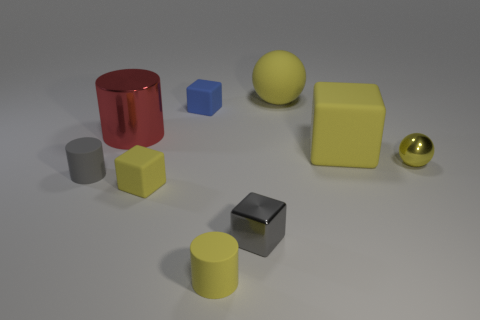Is there a small yellow rubber cube that is right of the yellow sphere that is in front of the small thing behind the tiny yellow ball?
Your response must be concise. No. What is the size of the rubber cylinder that is the same color as the metallic block?
Keep it short and to the point. Small. Are there any big matte things on the left side of the tiny yellow matte block?
Make the answer very short. No. How many other things are there of the same shape as the tiny gray rubber object?
Ensure brevity in your answer.  2. The shiny sphere that is the same size as the gray metallic thing is what color?
Make the answer very short. Yellow. Are there fewer things that are behind the gray cylinder than big red objects on the right side of the blue matte cube?
Offer a very short reply. No. How many large objects are in front of the yellow sphere left of the yellow ball that is in front of the big ball?
Your answer should be very brief. 2. The yellow object that is the same shape as the tiny gray matte object is what size?
Your answer should be very brief. Small. Are there any other things that are the same size as the yellow rubber ball?
Give a very brief answer. Yes. Are there fewer small gray shiny blocks that are behind the small shiny sphere than large things?
Your answer should be compact. Yes. 